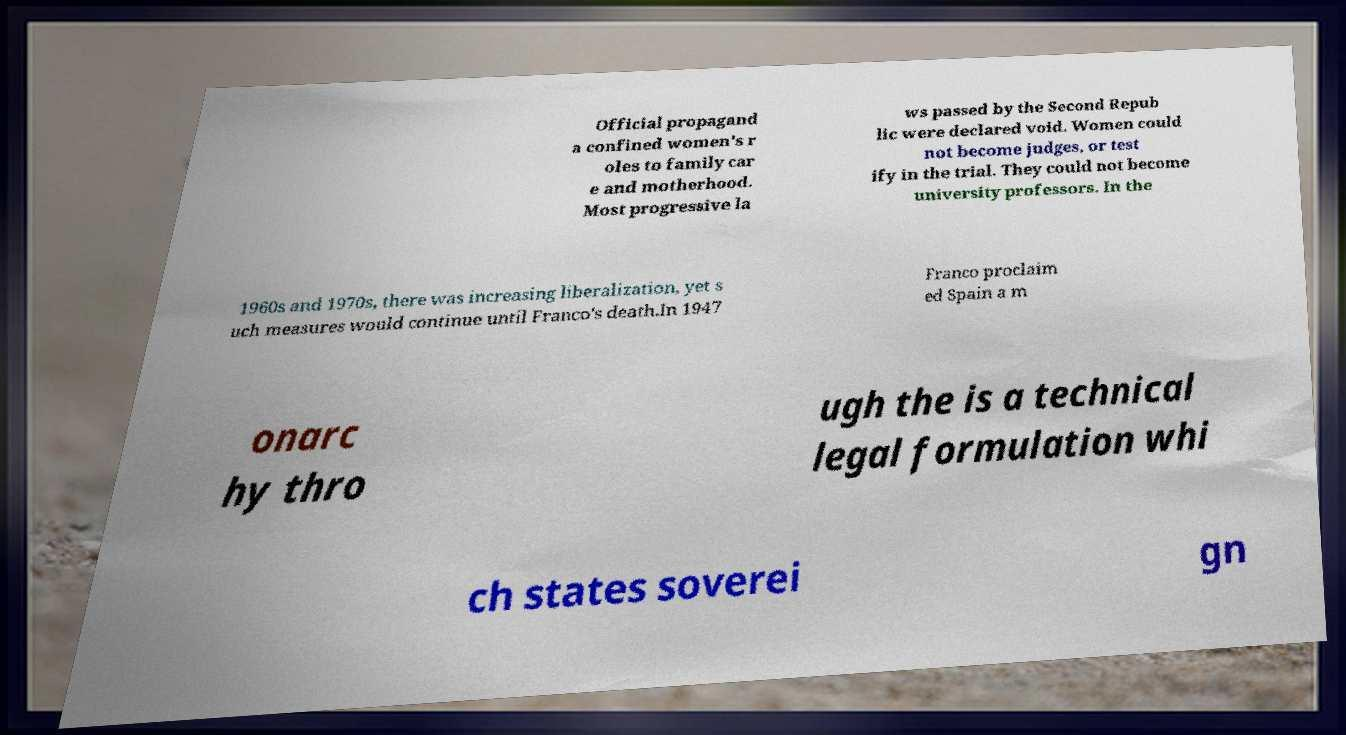What messages or text are displayed in this image? I need them in a readable, typed format. Official propagand a confined women's r oles to family car e and motherhood. Most progressive la ws passed by the Second Repub lic were declared void. Women could not become judges, or test ify in the trial. They could not become university professors. In the 1960s and 1970s, there was increasing liberalization, yet s uch measures would continue until Franco's death.In 1947 Franco proclaim ed Spain a m onarc hy thro ugh the is a technical legal formulation whi ch states soverei gn 